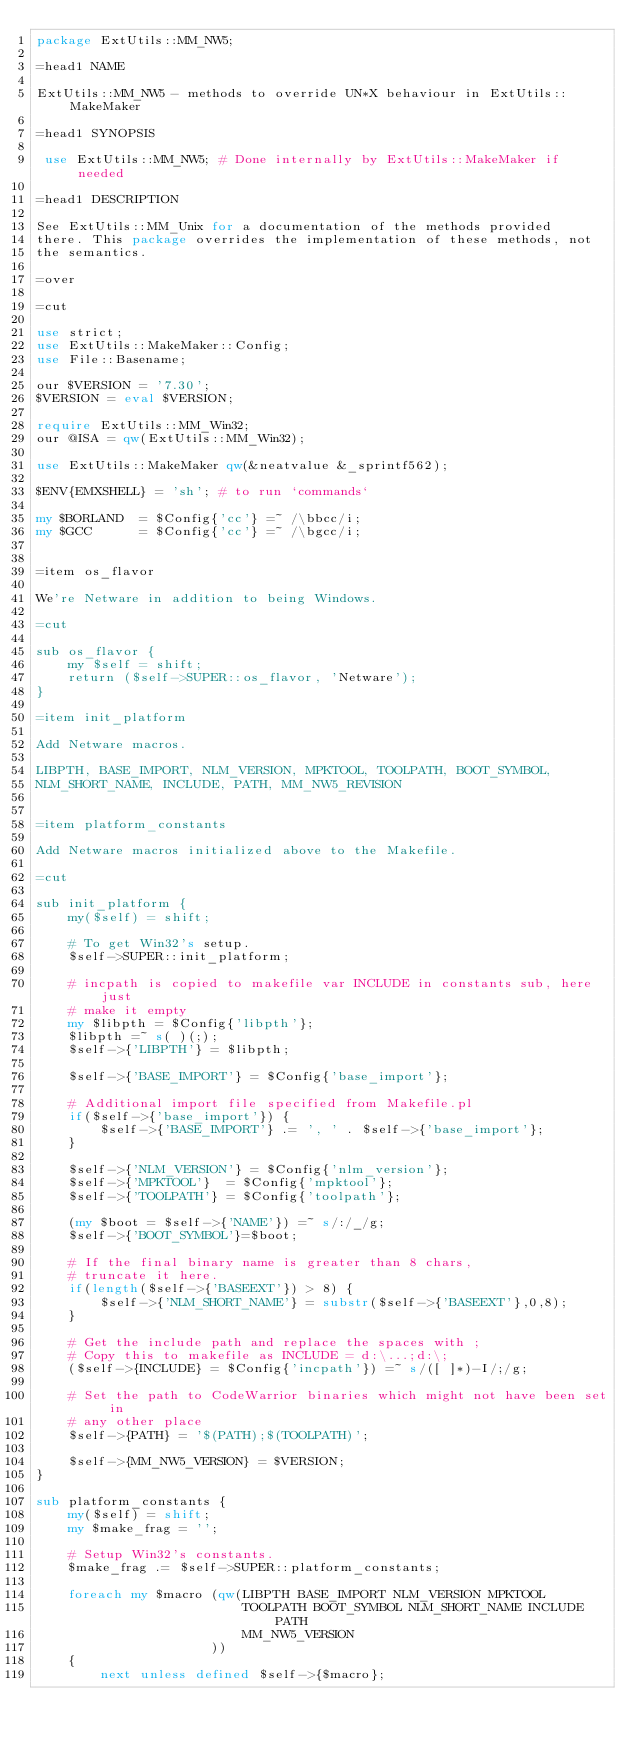<code> <loc_0><loc_0><loc_500><loc_500><_Perl_>package ExtUtils::MM_NW5;

=head1 NAME

ExtUtils::MM_NW5 - methods to override UN*X behaviour in ExtUtils::MakeMaker

=head1 SYNOPSIS

 use ExtUtils::MM_NW5; # Done internally by ExtUtils::MakeMaker if needed

=head1 DESCRIPTION

See ExtUtils::MM_Unix for a documentation of the methods provided
there. This package overrides the implementation of these methods, not
the semantics.

=over

=cut

use strict;
use ExtUtils::MakeMaker::Config;
use File::Basename;

our $VERSION = '7.30';
$VERSION = eval $VERSION;

require ExtUtils::MM_Win32;
our @ISA = qw(ExtUtils::MM_Win32);

use ExtUtils::MakeMaker qw(&neatvalue &_sprintf562);

$ENV{EMXSHELL} = 'sh'; # to run `commands`

my $BORLAND  = $Config{'cc'} =~ /\bbcc/i;
my $GCC      = $Config{'cc'} =~ /\bgcc/i;


=item os_flavor

We're Netware in addition to being Windows.

=cut

sub os_flavor {
    my $self = shift;
    return ($self->SUPER::os_flavor, 'Netware');
}

=item init_platform

Add Netware macros.

LIBPTH, BASE_IMPORT, NLM_VERSION, MPKTOOL, TOOLPATH, BOOT_SYMBOL,
NLM_SHORT_NAME, INCLUDE, PATH, MM_NW5_REVISION


=item platform_constants

Add Netware macros initialized above to the Makefile.

=cut

sub init_platform {
    my($self) = shift;

    # To get Win32's setup.
    $self->SUPER::init_platform;

    # incpath is copied to makefile var INCLUDE in constants sub, here just
    # make it empty
    my $libpth = $Config{'libpth'};
    $libpth =~ s( )(;);
    $self->{'LIBPTH'} = $libpth;

    $self->{'BASE_IMPORT'} = $Config{'base_import'};

    # Additional import file specified from Makefile.pl
    if($self->{'base_import'}) {
        $self->{'BASE_IMPORT'} .= ', ' . $self->{'base_import'};
    }

    $self->{'NLM_VERSION'} = $Config{'nlm_version'};
    $self->{'MPKTOOL'}	= $Config{'mpktool'};
    $self->{'TOOLPATH'}	= $Config{'toolpath'};

    (my $boot = $self->{'NAME'}) =~ s/:/_/g;
    $self->{'BOOT_SYMBOL'}=$boot;

    # If the final binary name is greater than 8 chars,
    # truncate it here.
    if(length($self->{'BASEEXT'}) > 8) {
        $self->{'NLM_SHORT_NAME'} = substr($self->{'BASEEXT'},0,8);
    }

    # Get the include path and replace the spaces with ;
    # Copy this to makefile as INCLUDE = d:\...;d:\;
    ($self->{INCLUDE} = $Config{'incpath'}) =~ s/([ ]*)-I/;/g;

    # Set the path to CodeWarrior binaries which might not have been set in
    # any other place
    $self->{PATH} = '$(PATH);$(TOOLPATH)';

    $self->{MM_NW5_VERSION} = $VERSION;
}

sub platform_constants {
    my($self) = shift;
    my $make_frag = '';

    # Setup Win32's constants.
    $make_frag .= $self->SUPER::platform_constants;

    foreach my $macro (qw(LIBPTH BASE_IMPORT NLM_VERSION MPKTOOL
                          TOOLPATH BOOT_SYMBOL NLM_SHORT_NAME INCLUDE PATH
                          MM_NW5_VERSION
                      ))
    {
        next unless defined $self->{$macro};</code> 